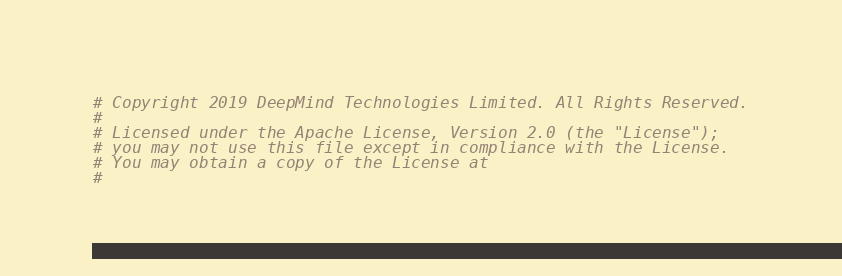<code> <loc_0><loc_0><loc_500><loc_500><_Python_># Copyright 2019 DeepMind Technologies Limited. All Rights Reserved.
#
# Licensed under the Apache License, Version 2.0 (the "License");
# you may not use this file except in compliance with the License.
# You may obtain a copy of the License at
#</code> 